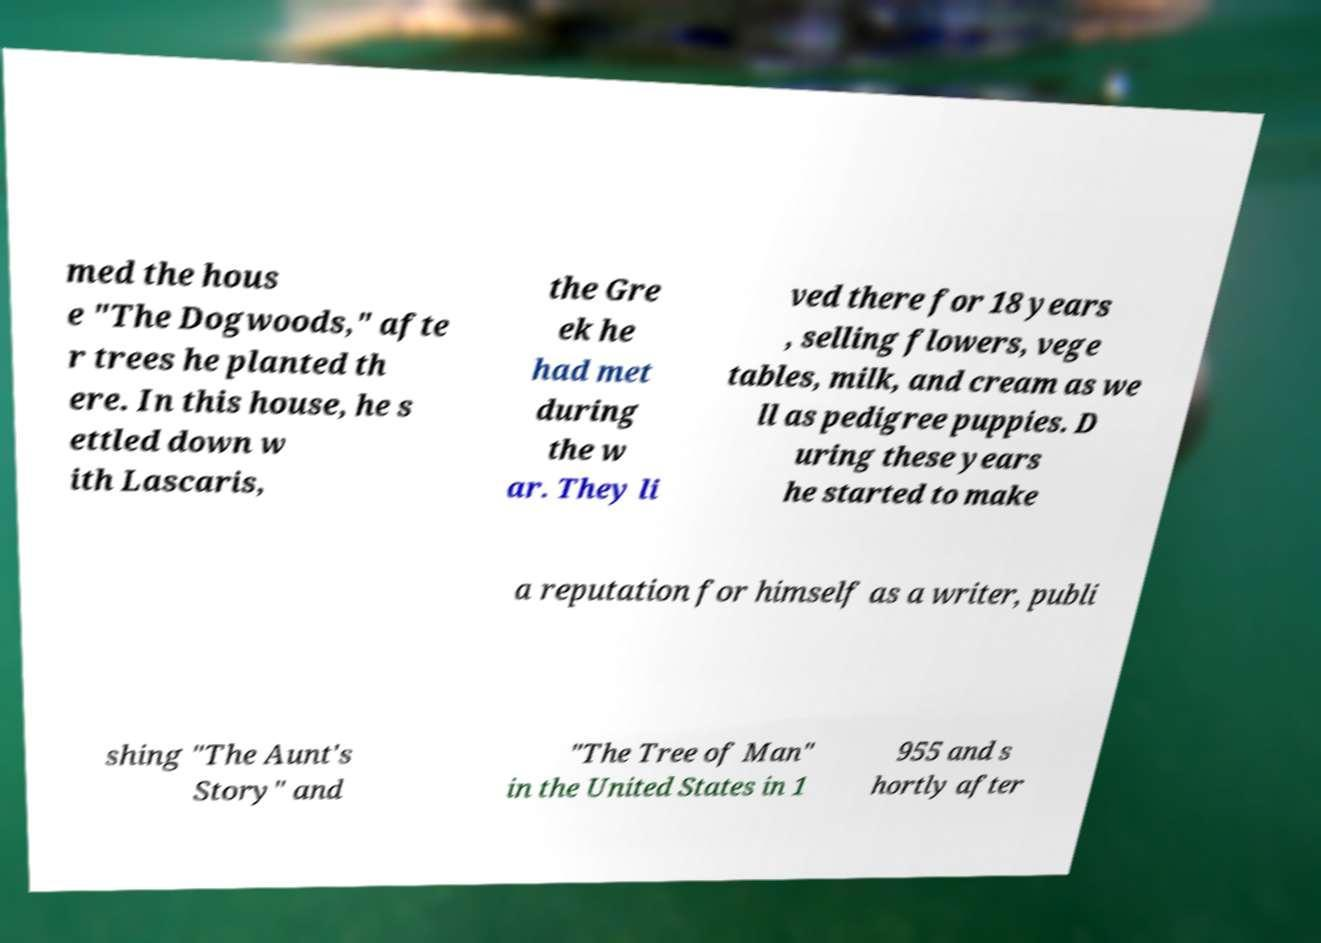Can you read and provide the text displayed in the image?This photo seems to have some interesting text. Can you extract and type it out for me? med the hous e "The Dogwoods," afte r trees he planted th ere. In this house, he s ettled down w ith Lascaris, the Gre ek he had met during the w ar. They li ved there for 18 years , selling flowers, vege tables, milk, and cream as we ll as pedigree puppies. D uring these years he started to make a reputation for himself as a writer, publi shing "The Aunt's Story" and "The Tree of Man" in the United States in 1 955 and s hortly after 